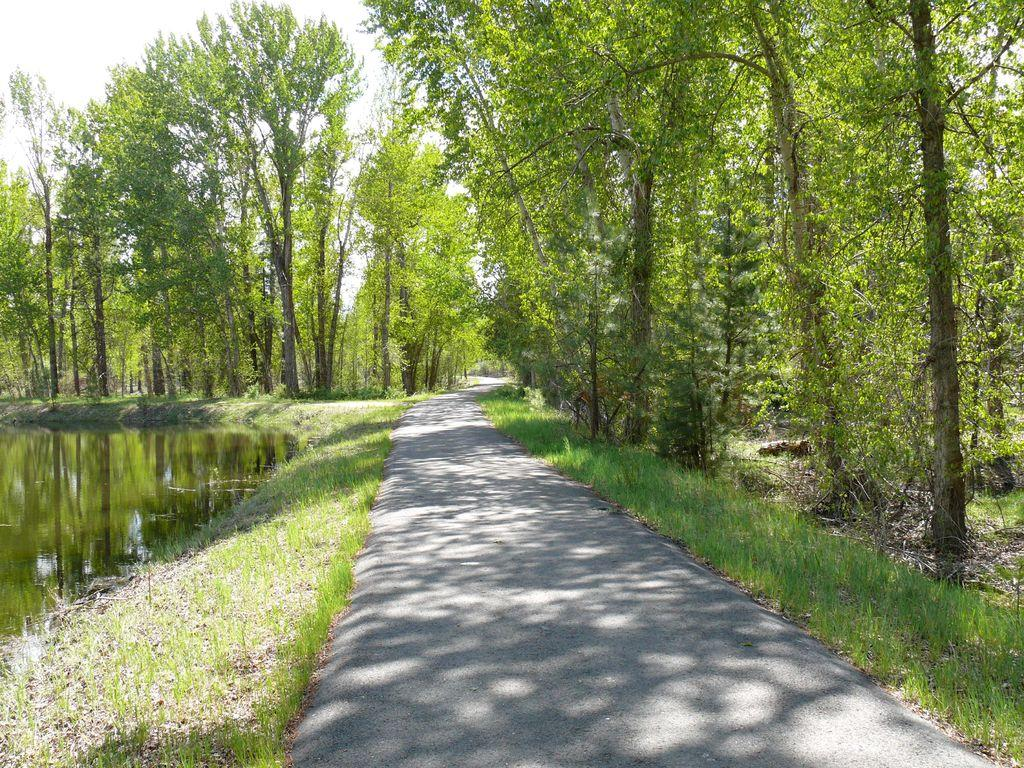What type of natural body of water is present in the image? There is a lake in the image. What type of man-made structure can be seen in the image? There is a road in the image. What type of vegetation is present in the image? There are many trees in the image. What type of dust can be seen covering the silver transport in the image? There is no dust, silver, or transport present in the image. What type of silver vehicle is visible in the image? There is no silver vehicle present in the image. 